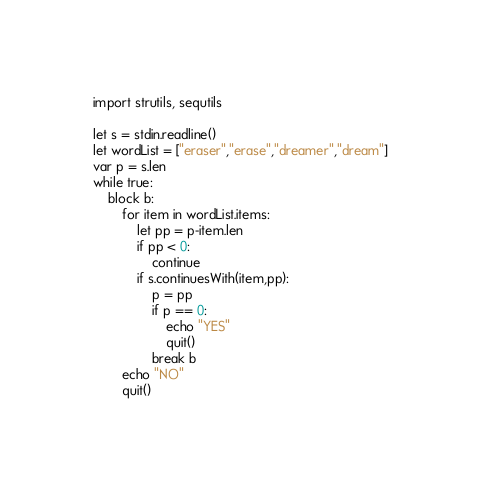Convert code to text. <code><loc_0><loc_0><loc_500><loc_500><_Nim_>import strutils, sequtils

let s = stdin.readline()
let wordList = ["eraser","erase","dreamer","dream"]
var p = s.len
while true:
    block b:
        for item in wordList.items:
            let pp = p-item.len
            if pp < 0:
                continue
            if s.continuesWith(item,pp):
                p = pp
                if p == 0:
                    echo "YES"
                    quit()
                break b
        echo "NO"
        quit()
</code> 